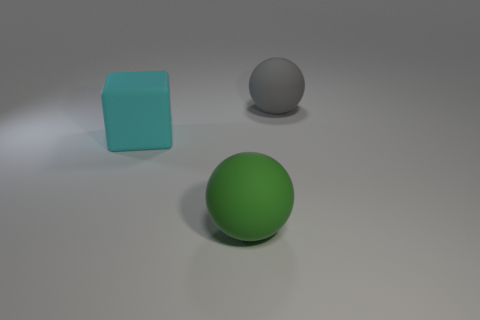Subtract all gray blocks. Subtract all purple spheres. How many blocks are left? 1 Add 2 spheres. How many objects exist? 5 Subtract all balls. How many objects are left? 1 Add 1 big matte spheres. How many big matte spheres exist? 3 Subtract 0 yellow balls. How many objects are left? 3 Subtract all big green matte spheres. Subtract all large green matte objects. How many objects are left? 1 Add 2 large green rubber balls. How many large green rubber balls are left? 3 